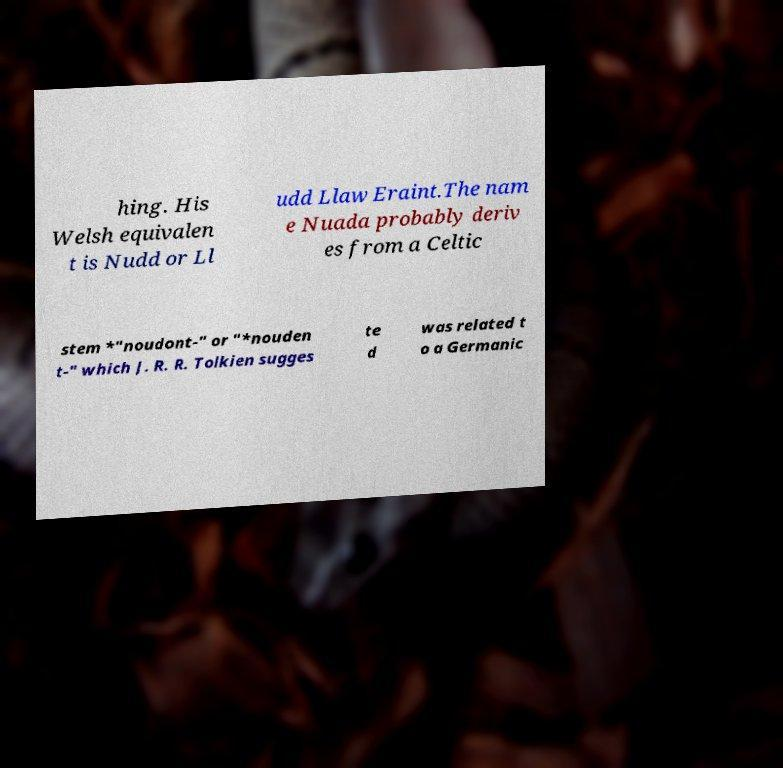Please read and relay the text visible in this image. What does it say? hing. His Welsh equivalen t is Nudd or Ll udd Llaw Eraint.The nam e Nuada probably deriv es from a Celtic stem *"noudont-" or "*nouden t-" which J. R. R. Tolkien sugges te d was related t o a Germanic 